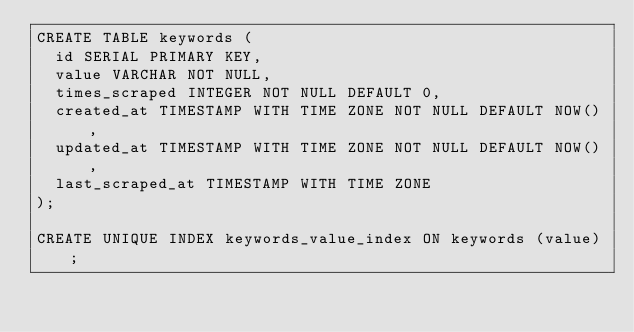<code> <loc_0><loc_0><loc_500><loc_500><_SQL_>CREATE TABLE keywords (
  id SERIAL PRIMARY KEY,
  value VARCHAR NOT NULL,
  times_scraped INTEGER NOT NULL DEFAULT 0,
  created_at TIMESTAMP WITH TIME ZONE NOT NULL DEFAULT NOW(),
  updated_at TIMESTAMP WITH TIME ZONE NOT NULL DEFAULT NOW(),
  last_scraped_at TIMESTAMP WITH TIME ZONE
);

CREATE UNIQUE INDEX keywords_value_index ON keywords (value);</code> 